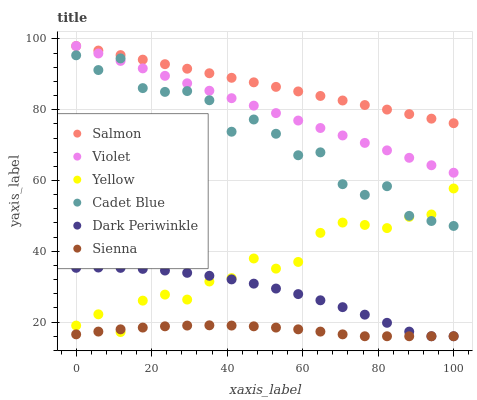Does Sienna have the minimum area under the curve?
Answer yes or no. Yes. Does Salmon have the maximum area under the curve?
Answer yes or no. Yes. Does Yellow have the minimum area under the curve?
Answer yes or no. No. Does Yellow have the maximum area under the curve?
Answer yes or no. No. Is Salmon the smoothest?
Answer yes or no. Yes. Is Cadet Blue the roughest?
Answer yes or no. Yes. Is Yellow the smoothest?
Answer yes or no. No. Is Yellow the roughest?
Answer yes or no. No. Does Sienna have the lowest value?
Answer yes or no. Yes. Does Yellow have the lowest value?
Answer yes or no. No. Does Violet have the highest value?
Answer yes or no. Yes. Does Yellow have the highest value?
Answer yes or no. No. Is Yellow less than Violet?
Answer yes or no. Yes. Is Violet greater than Yellow?
Answer yes or no. Yes. Does Sienna intersect Dark Periwinkle?
Answer yes or no. Yes. Is Sienna less than Dark Periwinkle?
Answer yes or no. No. Is Sienna greater than Dark Periwinkle?
Answer yes or no. No. Does Yellow intersect Violet?
Answer yes or no. No. 